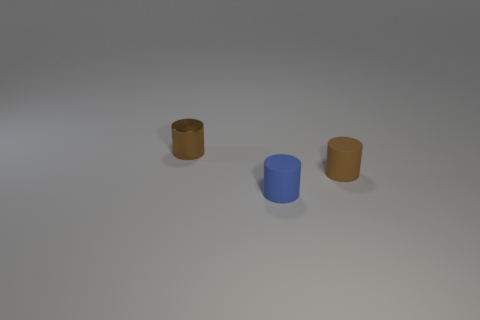Subtract all tiny brown matte cylinders. How many cylinders are left? 2 Subtract all blue cylinders. How many cylinders are left? 2 Subtract 2 cylinders. How many cylinders are left? 1 Add 3 matte things. How many objects exist? 6 Subtract all cyan balls. How many brown cylinders are left? 2 Subtract all small brown metallic cylinders. Subtract all gray shiny things. How many objects are left? 2 Add 3 tiny blue cylinders. How many tiny blue cylinders are left? 4 Add 2 large brown cylinders. How many large brown cylinders exist? 2 Subtract 0 green cylinders. How many objects are left? 3 Subtract all brown cylinders. Subtract all gray blocks. How many cylinders are left? 1 